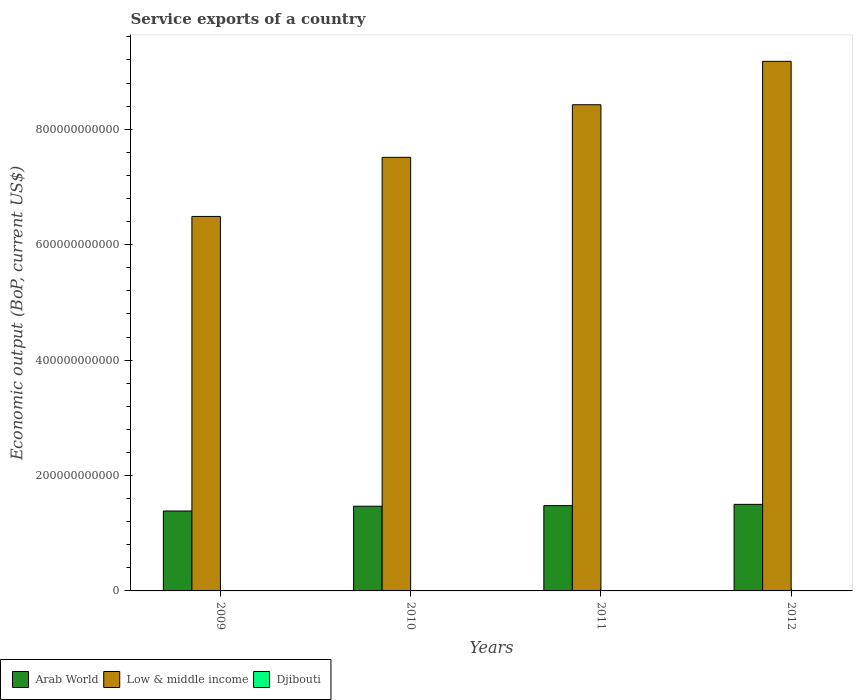Are the number of bars per tick equal to the number of legend labels?
Keep it short and to the point. Yes. How many bars are there on the 1st tick from the right?
Provide a short and direct response. 3. In how many cases, is the number of bars for a given year not equal to the number of legend labels?
Your answer should be very brief. 0. What is the service exports in Low & middle income in 2010?
Offer a very short reply. 7.51e+11. Across all years, what is the maximum service exports in Arab World?
Give a very brief answer. 1.50e+11. Across all years, what is the minimum service exports in Arab World?
Keep it short and to the point. 1.39e+11. In which year was the service exports in Arab World maximum?
Keep it short and to the point. 2012. What is the total service exports in Arab World in the graph?
Ensure brevity in your answer.  5.83e+11. What is the difference between the service exports in Low & middle income in 2009 and that in 2011?
Your answer should be compact. -1.94e+11. What is the difference between the service exports in Djibouti in 2011 and the service exports in Low & middle income in 2009?
Your answer should be very brief. -6.49e+11. What is the average service exports in Low & middle income per year?
Provide a succinct answer. 7.90e+11. In the year 2010, what is the difference between the service exports in Low & middle income and service exports in Arab World?
Offer a terse response. 6.05e+11. What is the ratio of the service exports in Arab World in 2009 to that in 2011?
Make the answer very short. 0.94. Is the service exports in Arab World in 2011 less than that in 2012?
Give a very brief answer. Yes. What is the difference between the highest and the second highest service exports in Low & middle income?
Offer a very short reply. 7.52e+1. What is the difference between the highest and the lowest service exports in Low & middle income?
Provide a short and direct response. 2.69e+11. Is the sum of the service exports in Djibouti in 2009 and 2011 greater than the maximum service exports in Arab World across all years?
Make the answer very short. No. What does the 3rd bar from the left in 2012 represents?
Provide a short and direct response. Djibouti. Is it the case that in every year, the sum of the service exports in Low & middle income and service exports in Djibouti is greater than the service exports in Arab World?
Your response must be concise. Yes. Are all the bars in the graph horizontal?
Your answer should be compact. No. What is the difference between two consecutive major ticks on the Y-axis?
Provide a succinct answer. 2.00e+11. Where does the legend appear in the graph?
Keep it short and to the point. Bottom left. What is the title of the graph?
Provide a succinct answer. Service exports of a country. What is the label or title of the Y-axis?
Ensure brevity in your answer.  Economic output (BoP, current US$). What is the Economic output (BoP, current US$) in Arab World in 2009?
Keep it short and to the point. 1.39e+11. What is the Economic output (BoP, current US$) in Low & middle income in 2009?
Ensure brevity in your answer.  6.49e+11. What is the Economic output (BoP, current US$) of Djibouti in 2009?
Offer a very short reply. 3.14e+08. What is the Economic output (BoP, current US$) in Arab World in 2010?
Offer a terse response. 1.47e+11. What is the Economic output (BoP, current US$) in Low & middle income in 2010?
Provide a short and direct response. 7.51e+11. What is the Economic output (BoP, current US$) in Djibouti in 2010?
Keep it short and to the point. 3.28e+08. What is the Economic output (BoP, current US$) of Arab World in 2011?
Provide a short and direct response. 1.48e+11. What is the Economic output (BoP, current US$) in Low & middle income in 2011?
Your response must be concise. 8.42e+11. What is the Economic output (BoP, current US$) of Djibouti in 2011?
Give a very brief answer. 3.19e+08. What is the Economic output (BoP, current US$) of Arab World in 2012?
Provide a short and direct response. 1.50e+11. What is the Economic output (BoP, current US$) in Low & middle income in 2012?
Ensure brevity in your answer.  9.18e+11. What is the Economic output (BoP, current US$) of Djibouti in 2012?
Offer a terse response. 3.31e+08. Across all years, what is the maximum Economic output (BoP, current US$) of Arab World?
Keep it short and to the point. 1.50e+11. Across all years, what is the maximum Economic output (BoP, current US$) in Low & middle income?
Offer a terse response. 9.18e+11. Across all years, what is the maximum Economic output (BoP, current US$) in Djibouti?
Your answer should be compact. 3.31e+08. Across all years, what is the minimum Economic output (BoP, current US$) in Arab World?
Make the answer very short. 1.39e+11. Across all years, what is the minimum Economic output (BoP, current US$) in Low & middle income?
Your response must be concise. 6.49e+11. Across all years, what is the minimum Economic output (BoP, current US$) in Djibouti?
Offer a very short reply. 3.14e+08. What is the total Economic output (BoP, current US$) in Arab World in the graph?
Keep it short and to the point. 5.83e+11. What is the total Economic output (BoP, current US$) of Low & middle income in the graph?
Keep it short and to the point. 3.16e+12. What is the total Economic output (BoP, current US$) of Djibouti in the graph?
Ensure brevity in your answer.  1.29e+09. What is the difference between the Economic output (BoP, current US$) of Arab World in 2009 and that in 2010?
Your answer should be compact. -8.29e+09. What is the difference between the Economic output (BoP, current US$) in Low & middle income in 2009 and that in 2010?
Give a very brief answer. -1.02e+11. What is the difference between the Economic output (BoP, current US$) of Djibouti in 2009 and that in 2010?
Keep it short and to the point. -1.36e+07. What is the difference between the Economic output (BoP, current US$) of Arab World in 2009 and that in 2011?
Your answer should be very brief. -9.29e+09. What is the difference between the Economic output (BoP, current US$) in Low & middle income in 2009 and that in 2011?
Your answer should be very brief. -1.94e+11. What is the difference between the Economic output (BoP, current US$) in Djibouti in 2009 and that in 2011?
Offer a very short reply. -4.65e+06. What is the difference between the Economic output (BoP, current US$) in Arab World in 2009 and that in 2012?
Provide a succinct answer. -1.15e+1. What is the difference between the Economic output (BoP, current US$) in Low & middle income in 2009 and that in 2012?
Your answer should be compact. -2.69e+11. What is the difference between the Economic output (BoP, current US$) in Djibouti in 2009 and that in 2012?
Ensure brevity in your answer.  -1.67e+07. What is the difference between the Economic output (BoP, current US$) of Arab World in 2010 and that in 2011?
Make the answer very short. -9.92e+08. What is the difference between the Economic output (BoP, current US$) in Low & middle income in 2010 and that in 2011?
Your response must be concise. -9.12e+1. What is the difference between the Economic output (BoP, current US$) of Djibouti in 2010 and that in 2011?
Your answer should be very brief. 8.94e+06. What is the difference between the Economic output (BoP, current US$) of Arab World in 2010 and that in 2012?
Your answer should be very brief. -3.17e+09. What is the difference between the Economic output (BoP, current US$) of Low & middle income in 2010 and that in 2012?
Provide a short and direct response. -1.66e+11. What is the difference between the Economic output (BoP, current US$) in Djibouti in 2010 and that in 2012?
Provide a succinct answer. -3.07e+06. What is the difference between the Economic output (BoP, current US$) of Arab World in 2011 and that in 2012?
Keep it short and to the point. -2.18e+09. What is the difference between the Economic output (BoP, current US$) in Low & middle income in 2011 and that in 2012?
Your answer should be very brief. -7.52e+1. What is the difference between the Economic output (BoP, current US$) of Djibouti in 2011 and that in 2012?
Keep it short and to the point. -1.20e+07. What is the difference between the Economic output (BoP, current US$) of Arab World in 2009 and the Economic output (BoP, current US$) of Low & middle income in 2010?
Offer a very short reply. -6.13e+11. What is the difference between the Economic output (BoP, current US$) in Arab World in 2009 and the Economic output (BoP, current US$) in Djibouti in 2010?
Provide a short and direct response. 1.38e+11. What is the difference between the Economic output (BoP, current US$) of Low & middle income in 2009 and the Economic output (BoP, current US$) of Djibouti in 2010?
Your answer should be compact. 6.49e+11. What is the difference between the Economic output (BoP, current US$) in Arab World in 2009 and the Economic output (BoP, current US$) in Low & middle income in 2011?
Your answer should be compact. -7.04e+11. What is the difference between the Economic output (BoP, current US$) in Arab World in 2009 and the Economic output (BoP, current US$) in Djibouti in 2011?
Make the answer very short. 1.38e+11. What is the difference between the Economic output (BoP, current US$) of Low & middle income in 2009 and the Economic output (BoP, current US$) of Djibouti in 2011?
Offer a terse response. 6.49e+11. What is the difference between the Economic output (BoP, current US$) in Arab World in 2009 and the Economic output (BoP, current US$) in Low & middle income in 2012?
Make the answer very short. -7.79e+11. What is the difference between the Economic output (BoP, current US$) in Arab World in 2009 and the Economic output (BoP, current US$) in Djibouti in 2012?
Ensure brevity in your answer.  1.38e+11. What is the difference between the Economic output (BoP, current US$) of Low & middle income in 2009 and the Economic output (BoP, current US$) of Djibouti in 2012?
Offer a very short reply. 6.49e+11. What is the difference between the Economic output (BoP, current US$) in Arab World in 2010 and the Economic output (BoP, current US$) in Low & middle income in 2011?
Your answer should be very brief. -6.96e+11. What is the difference between the Economic output (BoP, current US$) of Arab World in 2010 and the Economic output (BoP, current US$) of Djibouti in 2011?
Offer a terse response. 1.46e+11. What is the difference between the Economic output (BoP, current US$) in Low & middle income in 2010 and the Economic output (BoP, current US$) in Djibouti in 2011?
Provide a succinct answer. 7.51e+11. What is the difference between the Economic output (BoP, current US$) of Arab World in 2010 and the Economic output (BoP, current US$) of Low & middle income in 2012?
Offer a very short reply. -7.71e+11. What is the difference between the Economic output (BoP, current US$) in Arab World in 2010 and the Economic output (BoP, current US$) in Djibouti in 2012?
Your response must be concise. 1.46e+11. What is the difference between the Economic output (BoP, current US$) in Low & middle income in 2010 and the Economic output (BoP, current US$) in Djibouti in 2012?
Your answer should be compact. 7.51e+11. What is the difference between the Economic output (BoP, current US$) in Arab World in 2011 and the Economic output (BoP, current US$) in Low & middle income in 2012?
Give a very brief answer. -7.70e+11. What is the difference between the Economic output (BoP, current US$) in Arab World in 2011 and the Economic output (BoP, current US$) in Djibouti in 2012?
Your answer should be compact. 1.47e+11. What is the difference between the Economic output (BoP, current US$) in Low & middle income in 2011 and the Economic output (BoP, current US$) in Djibouti in 2012?
Provide a short and direct response. 8.42e+11. What is the average Economic output (BoP, current US$) in Arab World per year?
Ensure brevity in your answer.  1.46e+11. What is the average Economic output (BoP, current US$) of Low & middle income per year?
Your answer should be compact. 7.90e+11. What is the average Economic output (BoP, current US$) in Djibouti per year?
Make the answer very short. 3.23e+08. In the year 2009, what is the difference between the Economic output (BoP, current US$) of Arab World and Economic output (BoP, current US$) of Low & middle income?
Offer a very short reply. -5.10e+11. In the year 2009, what is the difference between the Economic output (BoP, current US$) of Arab World and Economic output (BoP, current US$) of Djibouti?
Offer a very short reply. 1.38e+11. In the year 2009, what is the difference between the Economic output (BoP, current US$) of Low & middle income and Economic output (BoP, current US$) of Djibouti?
Make the answer very short. 6.49e+11. In the year 2010, what is the difference between the Economic output (BoP, current US$) in Arab World and Economic output (BoP, current US$) in Low & middle income?
Give a very brief answer. -6.05e+11. In the year 2010, what is the difference between the Economic output (BoP, current US$) in Arab World and Economic output (BoP, current US$) in Djibouti?
Provide a short and direct response. 1.46e+11. In the year 2010, what is the difference between the Economic output (BoP, current US$) of Low & middle income and Economic output (BoP, current US$) of Djibouti?
Your response must be concise. 7.51e+11. In the year 2011, what is the difference between the Economic output (BoP, current US$) of Arab World and Economic output (BoP, current US$) of Low & middle income?
Provide a short and direct response. -6.95e+11. In the year 2011, what is the difference between the Economic output (BoP, current US$) in Arab World and Economic output (BoP, current US$) in Djibouti?
Offer a very short reply. 1.47e+11. In the year 2011, what is the difference between the Economic output (BoP, current US$) in Low & middle income and Economic output (BoP, current US$) in Djibouti?
Your answer should be very brief. 8.42e+11. In the year 2012, what is the difference between the Economic output (BoP, current US$) in Arab World and Economic output (BoP, current US$) in Low & middle income?
Offer a very short reply. -7.68e+11. In the year 2012, what is the difference between the Economic output (BoP, current US$) in Arab World and Economic output (BoP, current US$) in Djibouti?
Your answer should be very brief. 1.50e+11. In the year 2012, what is the difference between the Economic output (BoP, current US$) of Low & middle income and Economic output (BoP, current US$) of Djibouti?
Keep it short and to the point. 9.17e+11. What is the ratio of the Economic output (BoP, current US$) in Arab World in 2009 to that in 2010?
Keep it short and to the point. 0.94. What is the ratio of the Economic output (BoP, current US$) in Low & middle income in 2009 to that in 2010?
Provide a succinct answer. 0.86. What is the ratio of the Economic output (BoP, current US$) of Djibouti in 2009 to that in 2010?
Ensure brevity in your answer.  0.96. What is the ratio of the Economic output (BoP, current US$) in Arab World in 2009 to that in 2011?
Offer a terse response. 0.94. What is the ratio of the Economic output (BoP, current US$) in Low & middle income in 2009 to that in 2011?
Provide a short and direct response. 0.77. What is the ratio of the Economic output (BoP, current US$) in Djibouti in 2009 to that in 2011?
Your answer should be compact. 0.99. What is the ratio of the Economic output (BoP, current US$) in Arab World in 2009 to that in 2012?
Your answer should be compact. 0.92. What is the ratio of the Economic output (BoP, current US$) in Low & middle income in 2009 to that in 2012?
Give a very brief answer. 0.71. What is the ratio of the Economic output (BoP, current US$) in Djibouti in 2009 to that in 2012?
Your response must be concise. 0.95. What is the ratio of the Economic output (BoP, current US$) in Low & middle income in 2010 to that in 2011?
Your response must be concise. 0.89. What is the ratio of the Economic output (BoP, current US$) of Djibouti in 2010 to that in 2011?
Offer a very short reply. 1.03. What is the ratio of the Economic output (BoP, current US$) of Arab World in 2010 to that in 2012?
Ensure brevity in your answer.  0.98. What is the ratio of the Economic output (BoP, current US$) of Low & middle income in 2010 to that in 2012?
Provide a succinct answer. 0.82. What is the ratio of the Economic output (BoP, current US$) of Arab World in 2011 to that in 2012?
Keep it short and to the point. 0.99. What is the ratio of the Economic output (BoP, current US$) of Low & middle income in 2011 to that in 2012?
Offer a very short reply. 0.92. What is the ratio of the Economic output (BoP, current US$) of Djibouti in 2011 to that in 2012?
Ensure brevity in your answer.  0.96. What is the difference between the highest and the second highest Economic output (BoP, current US$) in Arab World?
Your answer should be very brief. 2.18e+09. What is the difference between the highest and the second highest Economic output (BoP, current US$) of Low & middle income?
Your answer should be compact. 7.52e+1. What is the difference between the highest and the second highest Economic output (BoP, current US$) of Djibouti?
Keep it short and to the point. 3.07e+06. What is the difference between the highest and the lowest Economic output (BoP, current US$) of Arab World?
Offer a very short reply. 1.15e+1. What is the difference between the highest and the lowest Economic output (BoP, current US$) in Low & middle income?
Provide a succinct answer. 2.69e+11. What is the difference between the highest and the lowest Economic output (BoP, current US$) of Djibouti?
Keep it short and to the point. 1.67e+07. 